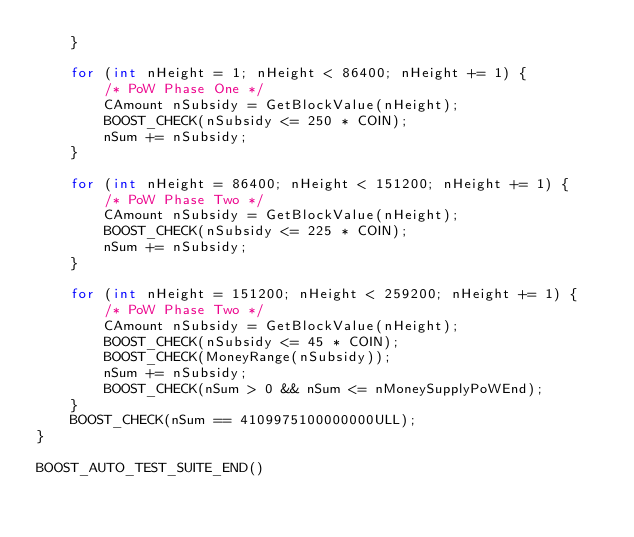Convert code to text. <code><loc_0><loc_0><loc_500><loc_500><_C++_>    }

    for (int nHeight = 1; nHeight < 86400; nHeight += 1) {
        /* PoW Phase One */
        CAmount nSubsidy = GetBlockValue(nHeight);
        BOOST_CHECK(nSubsidy <= 250 * COIN);
        nSum += nSubsidy;
    }

    for (int nHeight = 86400; nHeight < 151200; nHeight += 1) {
        /* PoW Phase Two */
        CAmount nSubsidy = GetBlockValue(nHeight);
        BOOST_CHECK(nSubsidy <= 225 * COIN);
        nSum += nSubsidy;
    }

    for (int nHeight = 151200; nHeight < 259200; nHeight += 1) {
        /* PoW Phase Two */
        CAmount nSubsidy = GetBlockValue(nHeight);
        BOOST_CHECK(nSubsidy <= 45 * COIN);
        BOOST_CHECK(MoneyRange(nSubsidy));
        nSum += nSubsidy;
        BOOST_CHECK(nSum > 0 && nSum <= nMoneySupplyPoWEnd);
    }
    BOOST_CHECK(nSum == 4109975100000000ULL);
}

BOOST_AUTO_TEST_SUITE_END()
</code> 